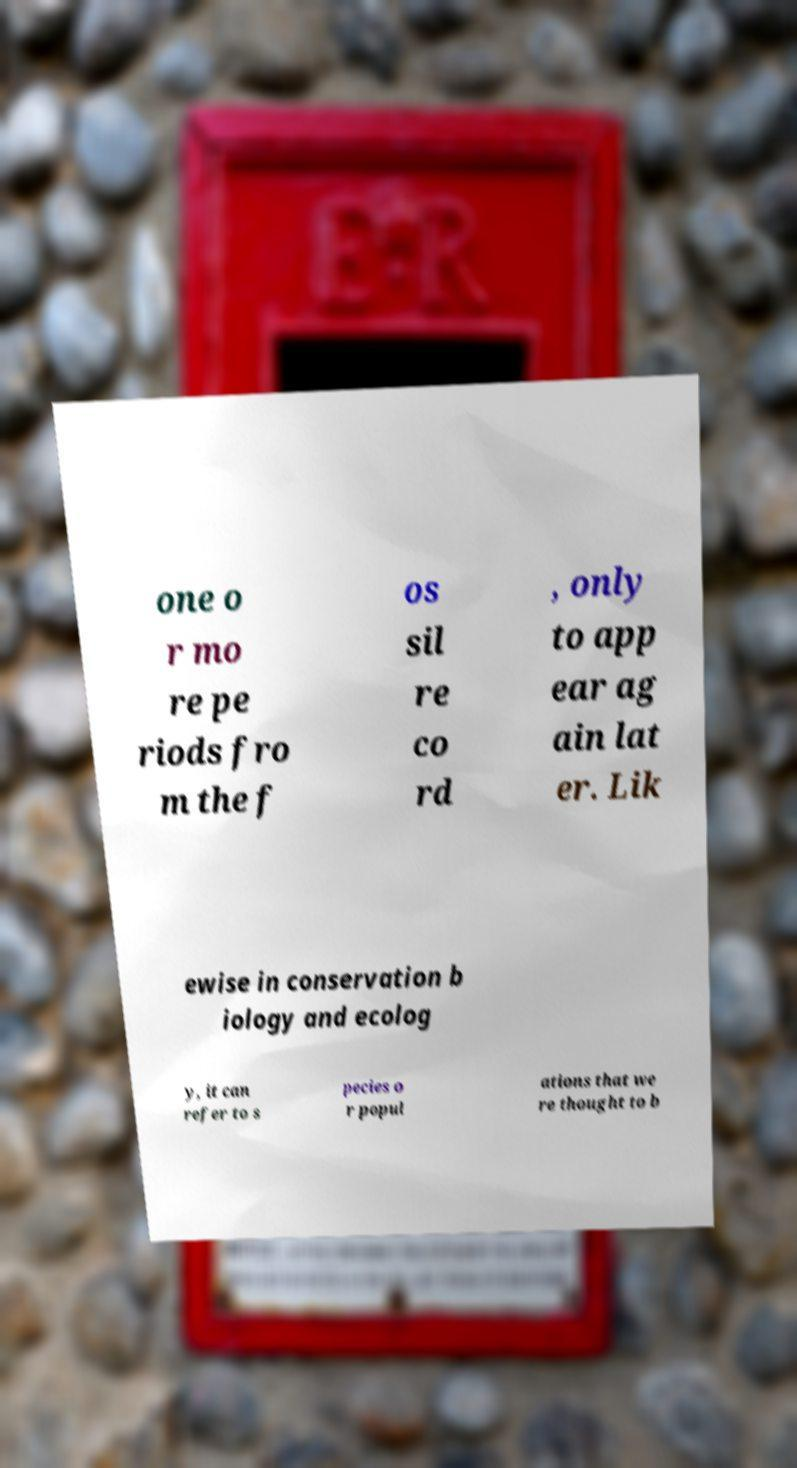Can you read and provide the text displayed in the image?This photo seems to have some interesting text. Can you extract and type it out for me? one o r mo re pe riods fro m the f os sil re co rd , only to app ear ag ain lat er. Lik ewise in conservation b iology and ecolog y, it can refer to s pecies o r popul ations that we re thought to b 